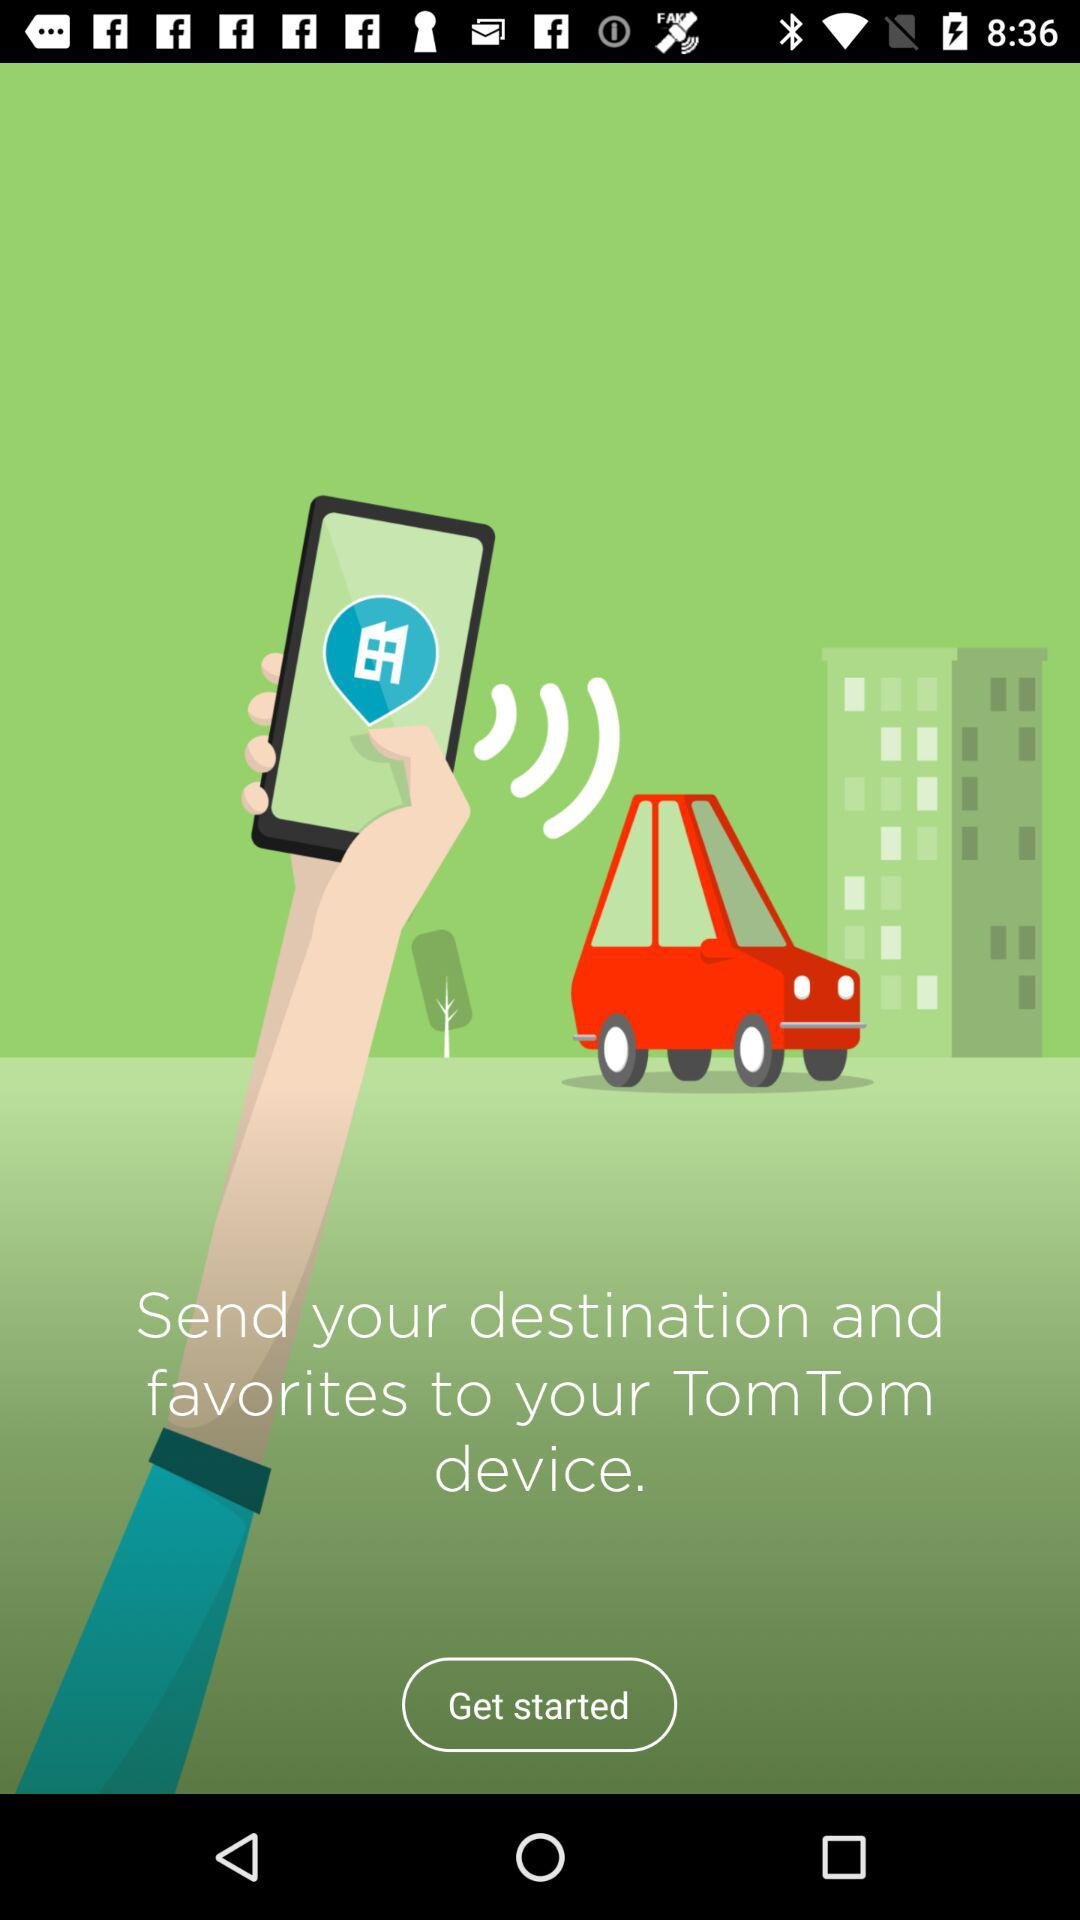To what device do we send our destinations and favorites? You send your destinations and favorites to your TomTom device. 